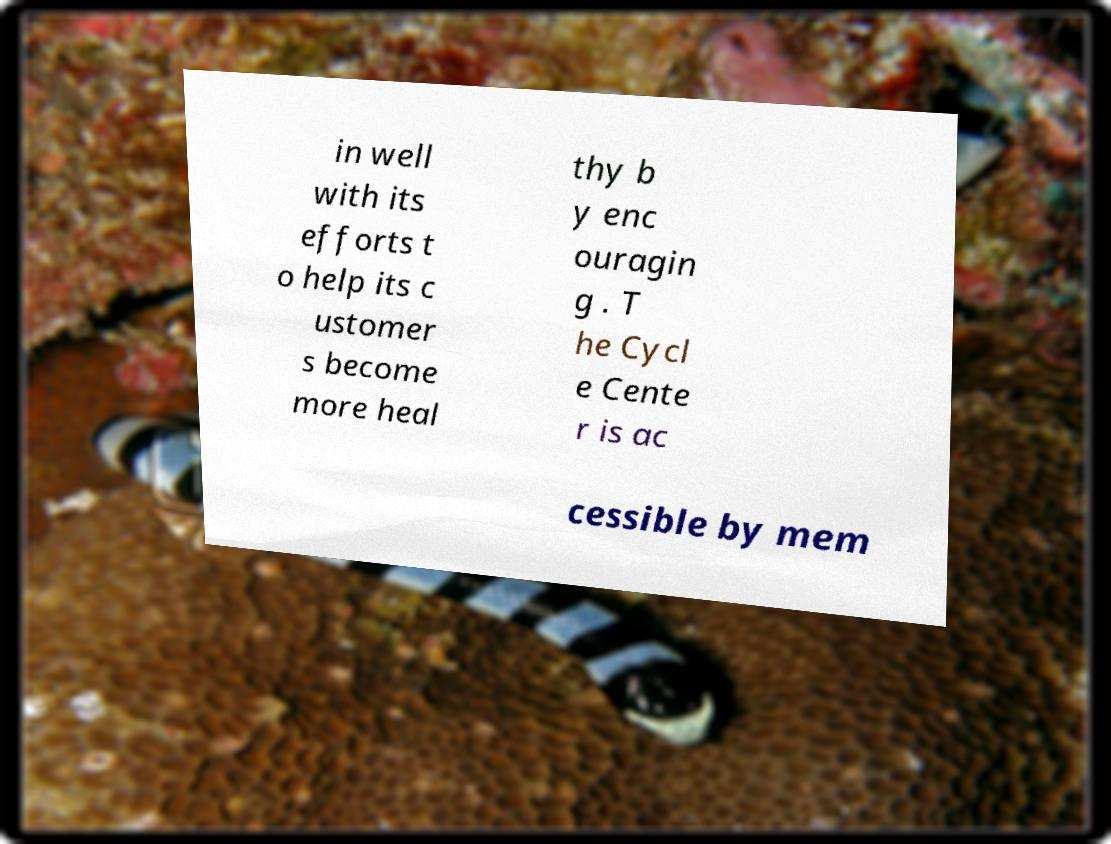Could you extract and type out the text from this image? in well with its efforts t o help its c ustomer s become more heal thy b y enc ouragin g . T he Cycl e Cente r is ac cessible by mem 